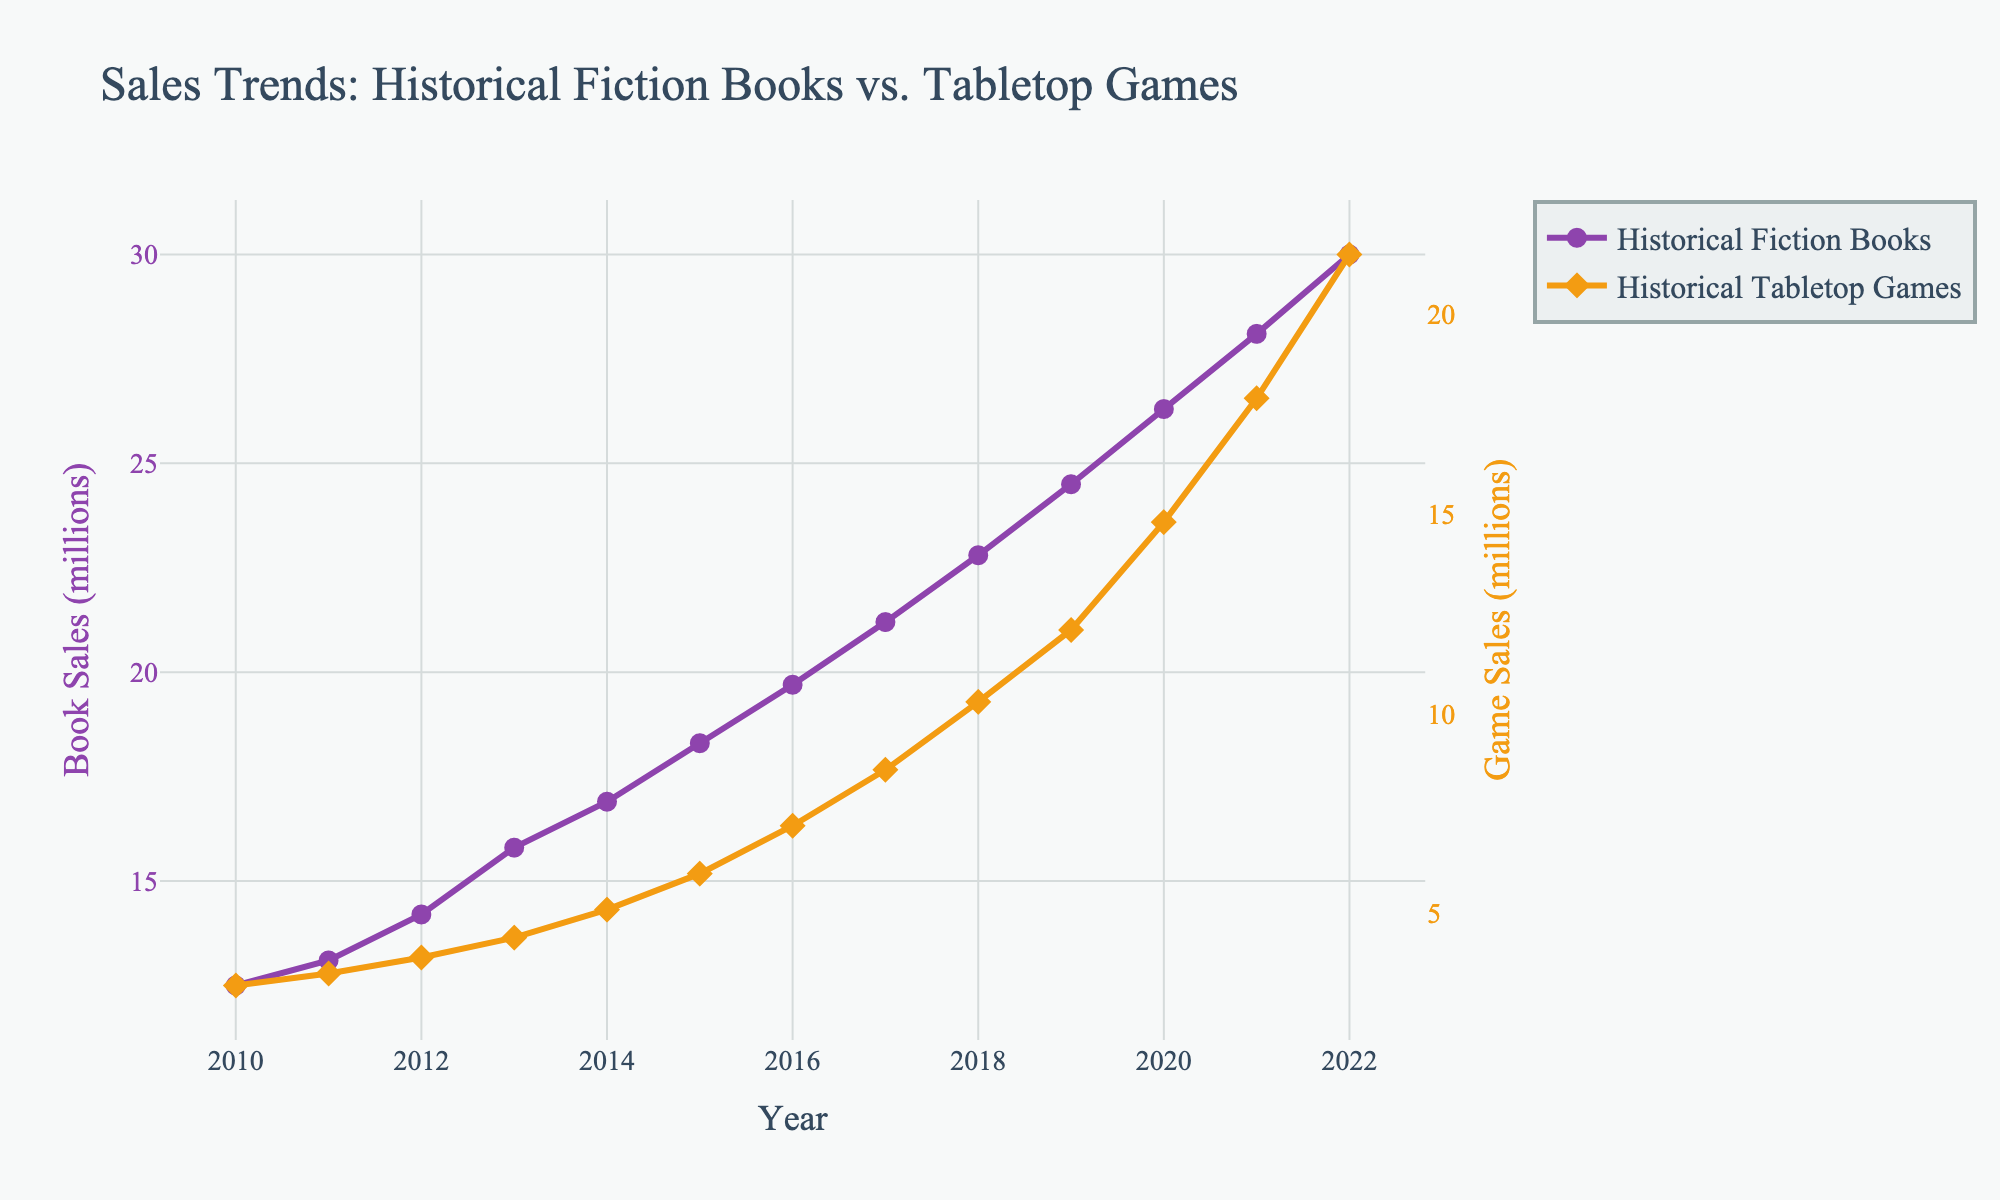What year did Historical Fiction Books and Historical Tabletop Games have their sales closest to each other? To find the year where the sales of the two categories were closest, we observe the gap between the lines for each year. The smallest gap appears in 2020 when the sales were 26.3 million for books and 14.8 million for games.
Answer: 2020 Which year had the highest sales growth for Historical Tabletop Games? To determine the highest growth year for Tabletop Games, compare the sales difference year to year. The largest increase was from 2021 to 2022, where sales went from 17.9 million to 21.5 million (an increase of 3.6 million).
Answer: 2022 What is the cumulative sales of Historical Fiction Books from 2010 to 2022? Calculate the sum of all yearly sales for Books: 12.5 + 13.1 + 14.2 + 15.8 + 16.9 + 18.3 + 19.7 + 21.2 + 22.8 + 24.5 + 26.3 + 28.1 + 30.0 = 263.4 million.
Answer: 263.4 million By how much did Historical Tabletop Games sales surpass 10 million? Determine the first year games sales surpassed 10 million and the amount exceeded. In 2018, games sales were 10.3 million, surpassing 10 million by 0.3 million.
Answer: 0.3 million During which year did Historical Fiction Books sales see the smallest increase from the previous year? Examine the annual increase for Books. The smallest increase was between 2010 and 2011, rising from 12.5 million to 13.1 million (an increase of 0.6 million).
Answer: 2011 Compare the sales growth of Historical Fiction Books and Historical Tabletop Games between 2015 and 2016. Which had the higher growth? The growth for Books was from 18.3 million to 19.7 million (1.4 million), while Games grew from 6.0 million to 7.2 million (1.2 million). Books had higher growth.
Answer: Historical Fiction Books What is the difference in sales between Historical Fiction Books and Historical Tabletop Games in 2022? Subtract games sales from books sales for 2022: 30.0 million - 21.5 million = 8.5 million.
Answer: 8.5 million What was the average yearly sales for Historical Tabletop Games from 2010 to 2022? Sum the yearly sales and divide by the number of years (13): (3.2 + 3.5 + 3.9 + 4.4 + 5.1 + 6.0 + 7.2 + 8.6 + 10.3 + 12.1 + 14.8 + 17.9 + 21.5) / 13 ≈ 9.12 million.
Answer: 9.12 million Which category had consistently higher sales over the years? Compare the values of both categories each year. Historical Fiction Books were always higher than Historical Tabletop Games.
Answer: Historical Fiction Books 